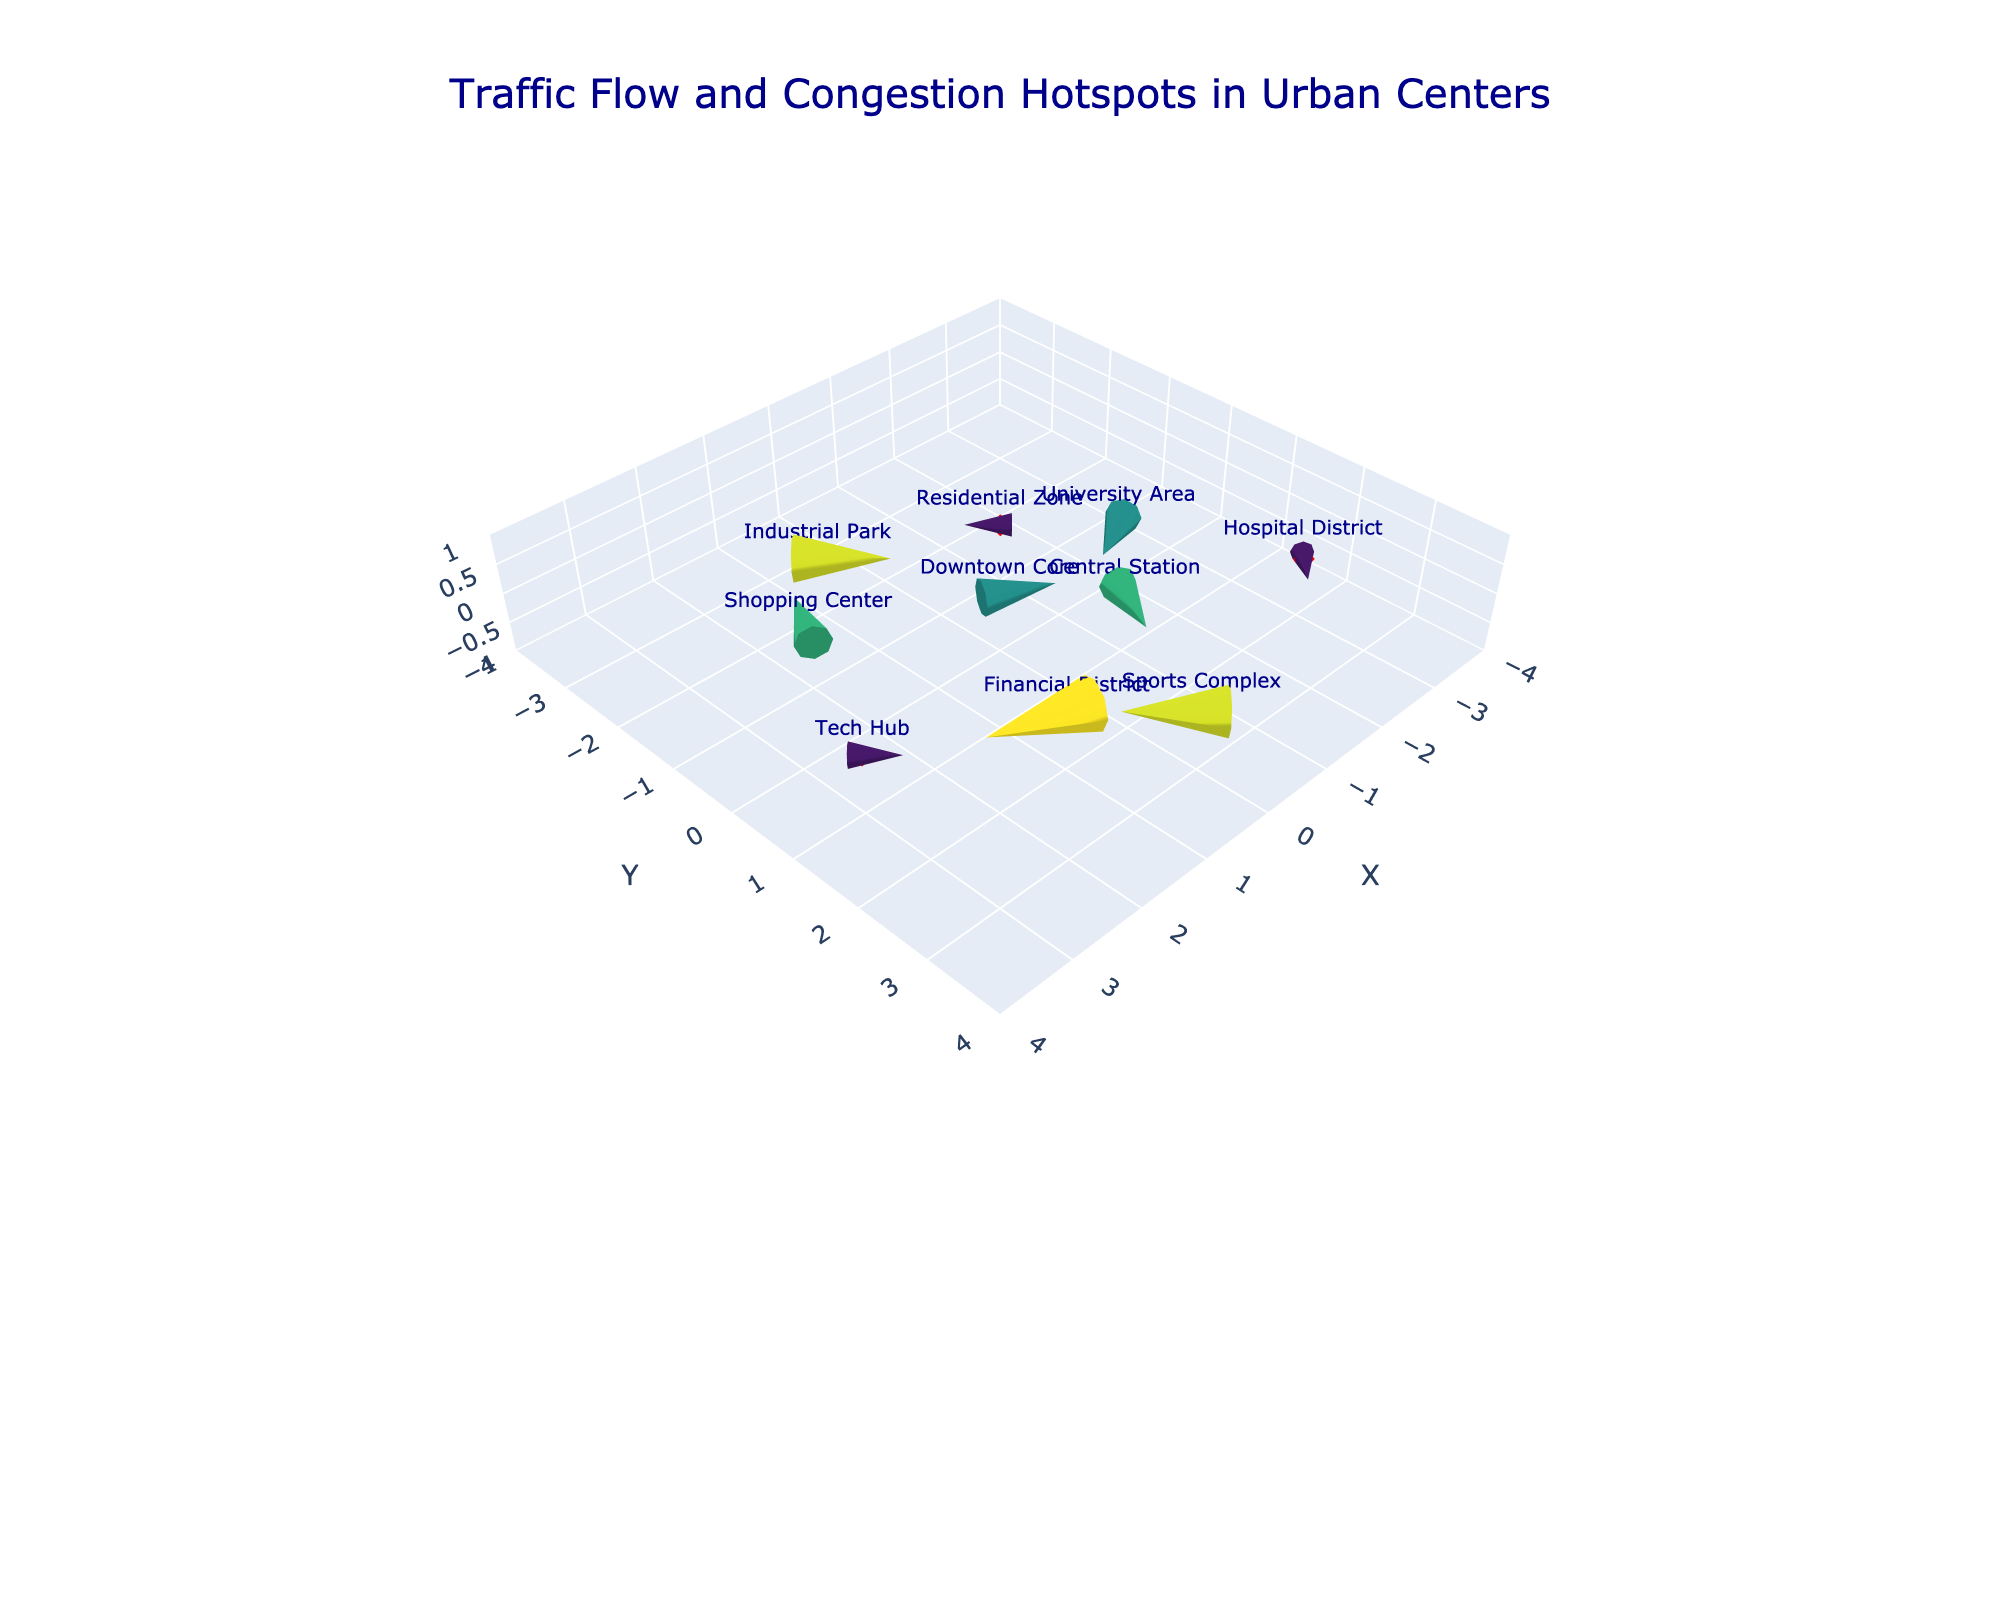What is the title of the plot? The title is usually displayed at the top of the plot and gives an overview of what the figure represents. In this case, it is centered and described in a larger font size.
Answer: Traffic Flow and Congestion Hotspots in Urban Centers How many data points are shown in this figure? Data points are usually indicated by the markers on the plot. Each location has a marker, so counting these markers gives the number of data points.
Answer: 10 Which locations experience traffic moving in the negative x-direction? Evaluate the 'u' component of the vectors for each data point. Locations with negative 'u' indicate traffic moving in the negative x-direction.
Answer: Downtown Core, Shopping Center, Industrial Park, Tech Hub Which location has the highest traffic magnitude? Identify the location associated with the highest value in the 'magnitude' column.
Answer: Financial District Which directions are traffic vectors pointing to in the Residential Zone? Look at the components 'u' and 'v' for the Residential Zone to determine the vector direction.
Answer: Positive x-direction and negative y-direction Which two locations have the same magnitude and traffic vectors moving in the same direction? Compare both magnitude and vector direction ('u' and 'v') for all pairs of locations.
Answer: Downtown Core and Central Station What is the overall trend in traffic flow in the Financial District compared to the Industrial Park? Compare the vector directions and magnitudes for these two locations. The Financial District has higher magnitudes with a vector (+3, -1) compared to the Industrial Park (-2, +2) suggesting different congestion patterns.
Answer: Financial District has more eastward flow, Industrial Park has more westward flow How many locations show a strong northward traffic component (positive y-direction)? Count the locations with a positive 'v' component to determine the northward traffic vectors.
Answer: 4 